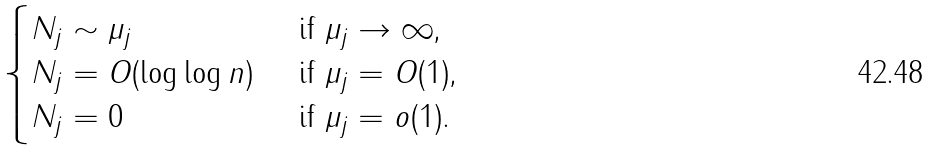<formula> <loc_0><loc_0><loc_500><loc_500>\begin{cases} N _ { j } \sim \mu _ { j } & \text { if $\mu_{j}\to \infty$,} \\ N _ { j } = O ( \log \log n ) & \text { if $\mu_{j} = O(1)$,} \\ N _ { j } = 0 & \text { if $\mu_{j} = o(1)$.} \end{cases}</formula> 